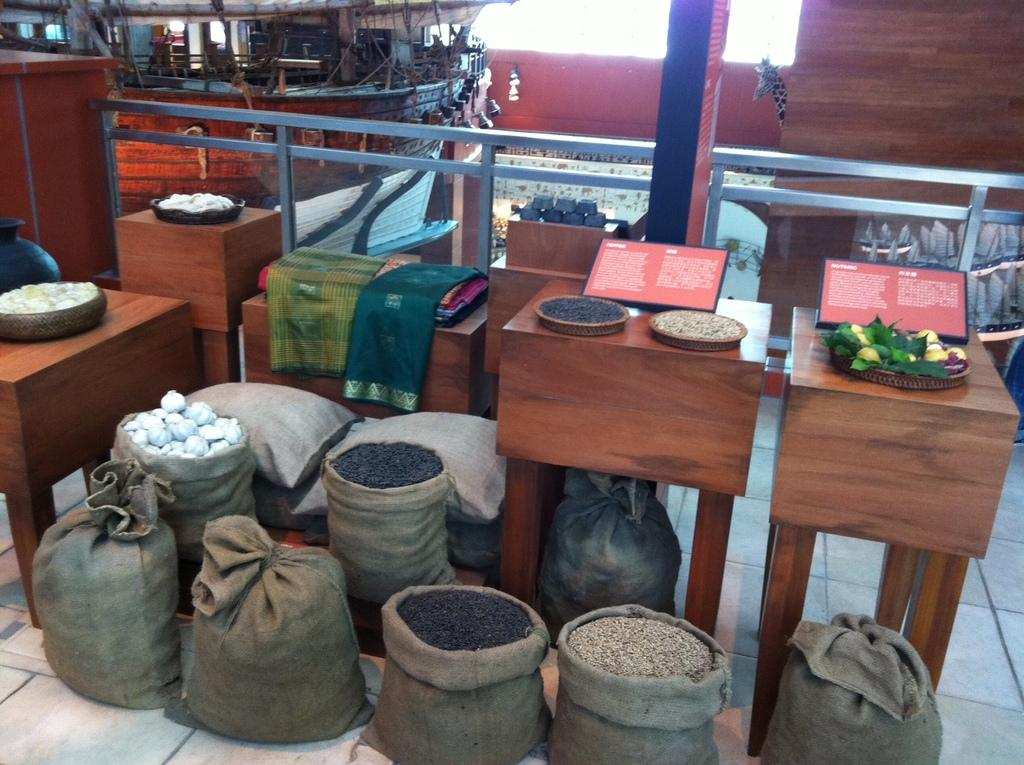What type of food items are present in the image? There are bags of grains and onions in the image. Can you describe the bags of grains in the image? The bags of grains are visible in the image. What nation is represented by the bags of grains in the image? The bags of grains do not represent any specific nation in the image. Are the onions hot in the image? The image does not provide information about the temperature of the onions. 